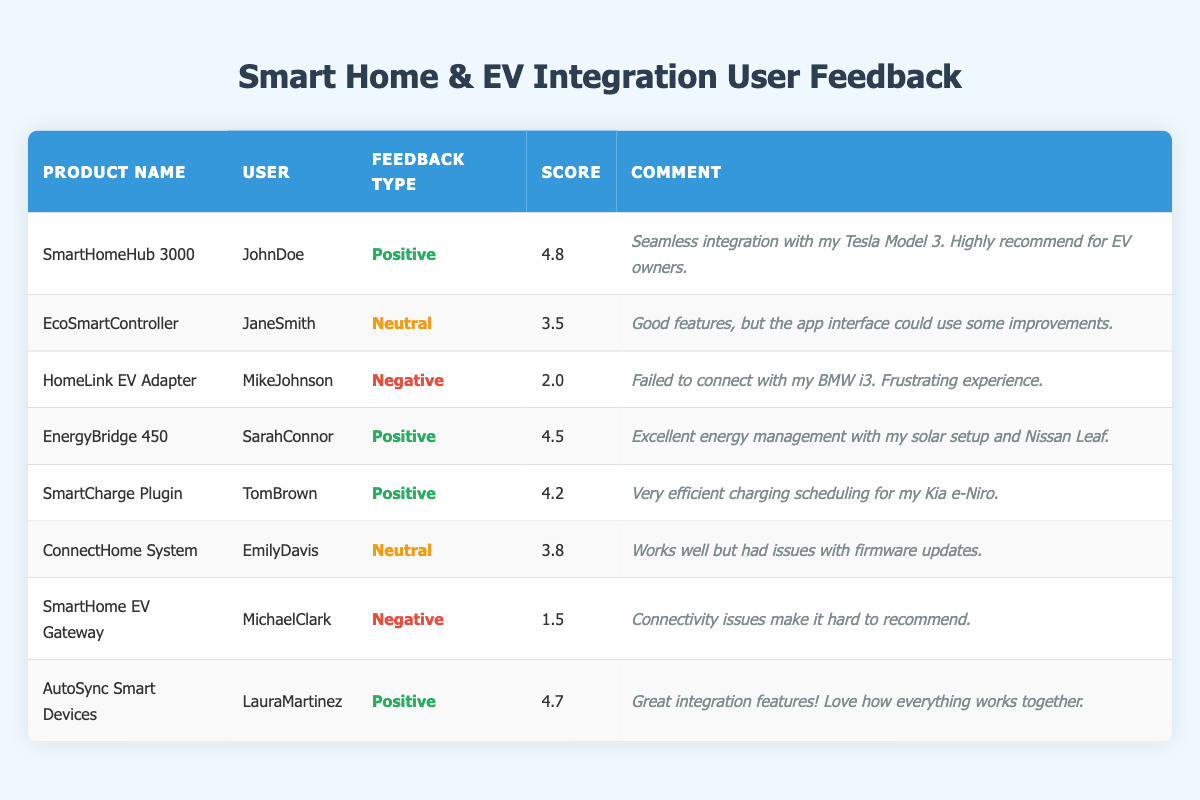What is the highest feedback score received among the products? The highest feedback score in the table is 4.8, which is given to the SmartHomeHub 3000.
Answer: 4.8 How many products received a positive feedback type? There are four products with a positive feedback type: SmartHomeHub 3000, EnergyBridge 450, SmartCharge Plugin, and AutoSync Smart Devices.
Answer: 4 What is the average feedback score of the neutral feedback products? The neutral feedback products are EcoSmartController with a score of 3.5 and ConnectHome System with a score of 3.8. Adding these together gives 3.5 + 3.8 = 7.3. Dividing by the number of neutral products (2) gives an average of 7.3 / 2 = 3.65.
Answer: 3.65 Did any of the products receive a score below 2.0? Yes, the SmartHome EV Gateway received a feedback score of 1.5, which is below 2.0.
Answer: Yes Which user provided feedback about the HomeLink EV Adapter, and what type of feedback did they give? The user Mike Johnson provided feedback for the HomeLink EV Adapter, and the feedback type was negative.
Answer: Mike Johnson, Negative What percentage of users gave positive feedback? There are 8 total feedback entries; 4 of them are positive. To find the percentage, (4 positive / 8 total) * 100 = 50%.
Answer: 50% How does the feedback score of EcoSmartController compare to that of SmartCharge Plugin? The EcoSmartController has a score of 3.5, and SmartCharge Plugin has a score of 4.2. Comparing these, SmartCharge Plugin's score is higher by 0.7 (4.2 - 3.5).
Answer: SmartCharge Plugin is 0.7 higher What is the total number of users who left feedback for the products? There are 8 different users who left feedback for the products: JohnDoe, JaneSmith, MikeJohnson, SarahConnor, TomBrown, EmilyDavis, MichaelClark, and LauraMartinez. Counting those gives a total of 8 users.
Answer: 8 